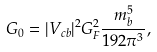Convert formula to latex. <formula><loc_0><loc_0><loc_500><loc_500>\ G _ { 0 } = | V _ { c b } | ^ { 2 } G _ { F } ^ { 2 } \frac { m _ { b } ^ { 5 } } { 1 9 2 \pi ^ { 3 } } ,</formula> 